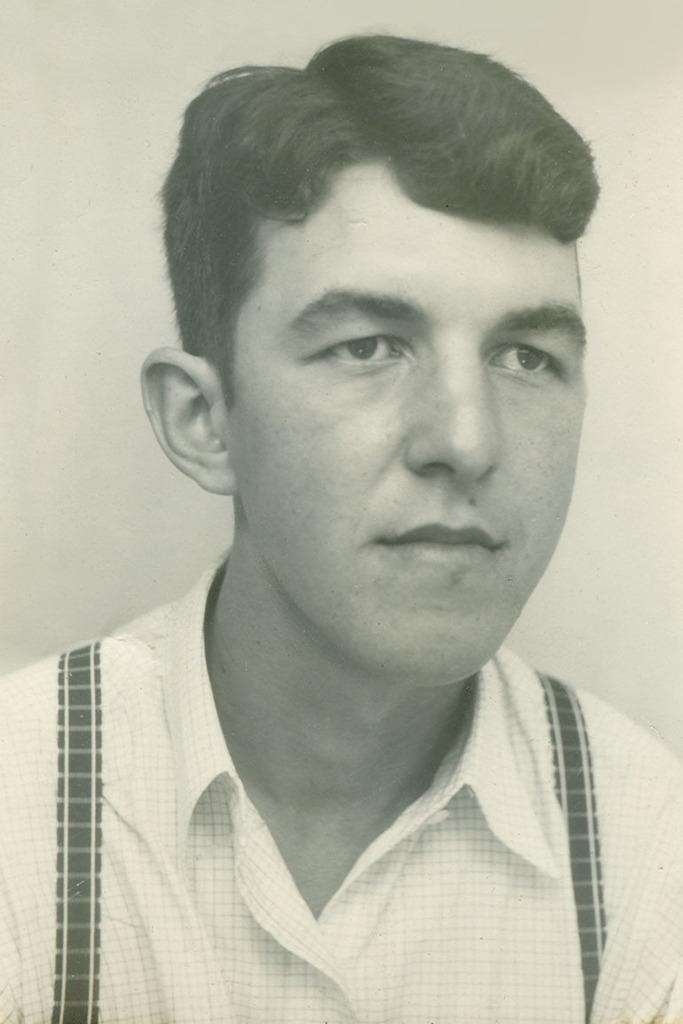Who or what is the main subject of the image? There is a person in the image. What is the person wearing? The person is wearing a white shirt. What can be seen in the background of the image? The background of the image is white. How many rabbits are visible in the image? There are no rabbits present in the image. What type of apple is being held by the person in the image? There is no apple present in the image. 